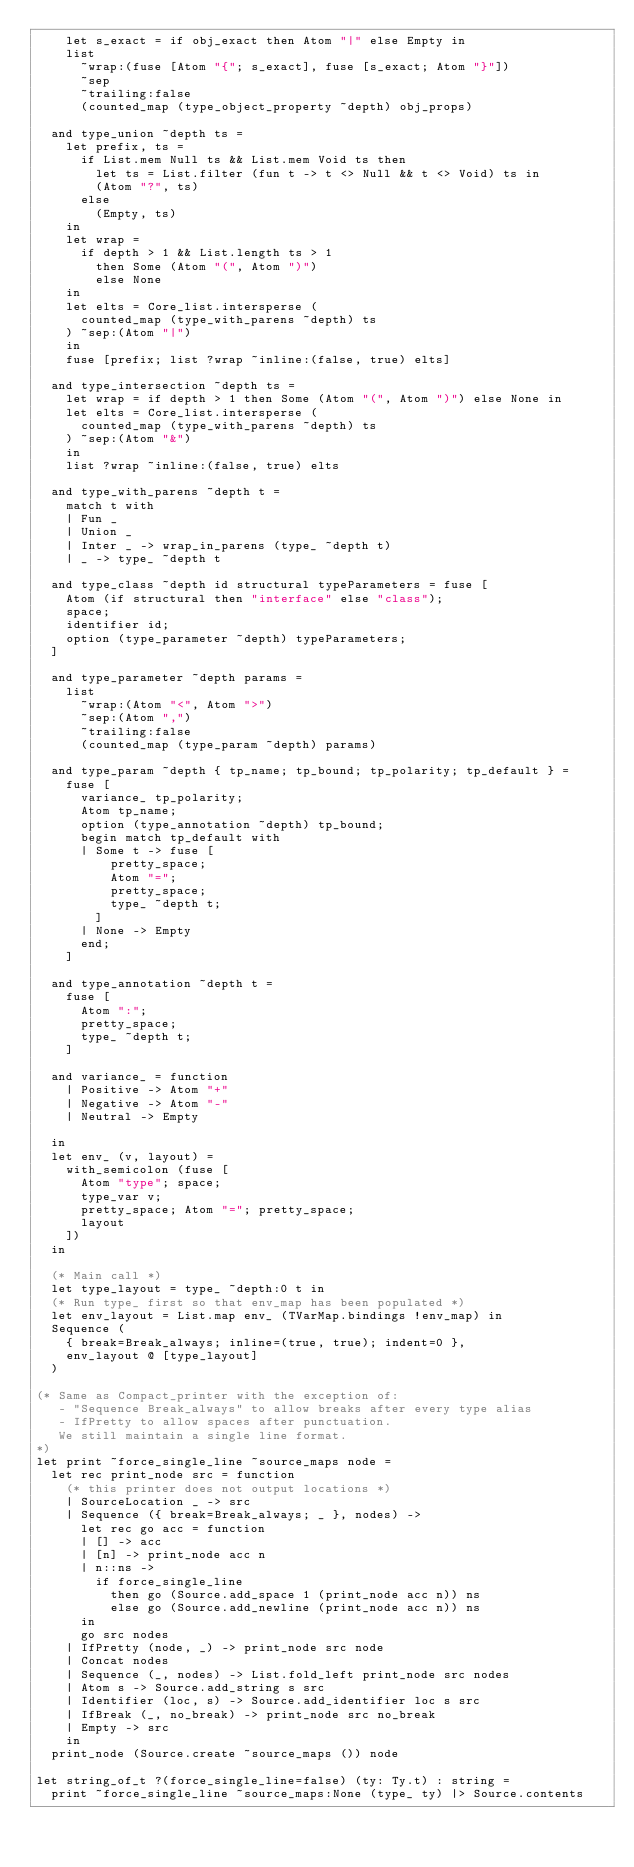Convert code to text. <code><loc_0><loc_0><loc_500><loc_500><_OCaml_>    let s_exact = if obj_exact then Atom "|" else Empty in
    list
      ~wrap:(fuse [Atom "{"; s_exact], fuse [s_exact; Atom "}"])
      ~sep
      ~trailing:false
      (counted_map (type_object_property ~depth) obj_props)

  and type_union ~depth ts =
    let prefix, ts =
      if List.mem Null ts && List.mem Void ts then
        let ts = List.filter (fun t -> t <> Null && t <> Void) ts in
        (Atom "?", ts)
      else
        (Empty, ts)
    in
    let wrap =
      if depth > 1 && List.length ts > 1
        then Some (Atom "(", Atom ")")
        else None
    in
    let elts = Core_list.intersperse (
      counted_map (type_with_parens ~depth) ts
    ) ~sep:(Atom "|")
    in
    fuse [prefix; list ?wrap ~inline:(false, true) elts]

  and type_intersection ~depth ts =
    let wrap = if depth > 1 then Some (Atom "(", Atom ")") else None in
    let elts = Core_list.intersperse (
      counted_map (type_with_parens ~depth) ts
    ) ~sep:(Atom "&")
    in
    list ?wrap ~inline:(false, true) elts

  and type_with_parens ~depth t =
    match t with
    | Fun _
    | Union _
    | Inter _ -> wrap_in_parens (type_ ~depth t)
    | _ -> type_ ~depth t

  and type_class ~depth id structural typeParameters = fuse [
    Atom (if structural then "interface" else "class");
    space;
    identifier id;
    option (type_parameter ~depth) typeParameters;
  ]

  and type_parameter ~depth params =
    list
      ~wrap:(Atom "<", Atom ">")
      ~sep:(Atom ",")
      ~trailing:false
      (counted_map (type_param ~depth) params)

  and type_param ~depth { tp_name; tp_bound; tp_polarity; tp_default } =
    fuse [
      variance_ tp_polarity;
      Atom tp_name;
      option (type_annotation ~depth) tp_bound;
      begin match tp_default with
      | Some t -> fuse [
          pretty_space;
          Atom "=";
          pretty_space;
          type_ ~depth t;
        ]
      | None -> Empty
      end;
    ]

  and type_annotation ~depth t =
    fuse [
      Atom ":";
      pretty_space;
      type_ ~depth t;
    ]

  and variance_ = function
    | Positive -> Atom "+"
    | Negative -> Atom "-"
    | Neutral -> Empty

  in
  let env_ (v, layout) =
    with_semicolon (fuse [
      Atom "type"; space;
      type_var v;
      pretty_space; Atom "="; pretty_space;
      layout
    ])
  in

  (* Main call *)
  let type_layout = type_ ~depth:0 t in
  (* Run type_ first so that env_map has been populated *)
  let env_layout = List.map env_ (TVarMap.bindings !env_map) in
  Sequence (
    { break=Break_always; inline=(true, true); indent=0 },
    env_layout @ [type_layout]
  )

(* Same as Compact_printer with the exception of:
   - "Sequence Break_always" to allow breaks after every type alias
   - IfPretty to allow spaces after punctuation.
   We still maintain a single line format.
*)
let print ~force_single_line ~source_maps node =
  let rec print_node src = function
    (* this printer does not output locations *)
    | SourceLocation _ -> src
    | Sequence ({ break=Break_always; _ }, nodes) ->
      let rec go acc = function
      | [] -> acc
      | [n] -> print_node acc n
      | n::ns ->
        if force_single_line
          then go (Source.add_space 1 (print_node acc n)) ns
          else go (Source.add_newline (print_node acc n)) ns
      in
      go src nodes
    | IfPretty (node, _) -> print_node src node
    | Concat nodes
    | Sequence (_, nodes) -> List.fold_left print_node src nodes
    | Atom s -> Source.add_string s src
    | Identifier (loc, s) -> Source.add_identifier loc s src
    | IfBreak (_, no_break) -> print_node src no_break
    | Empty -> src
    in
  print_node (Source.create ~source_maps ()) node

let string_of_t ?(force_single_line=false) (ty: Ty.t) : string =
  print ~force_single_line ~source_maps:None (type_ ty) |> Source.contents
</code> 